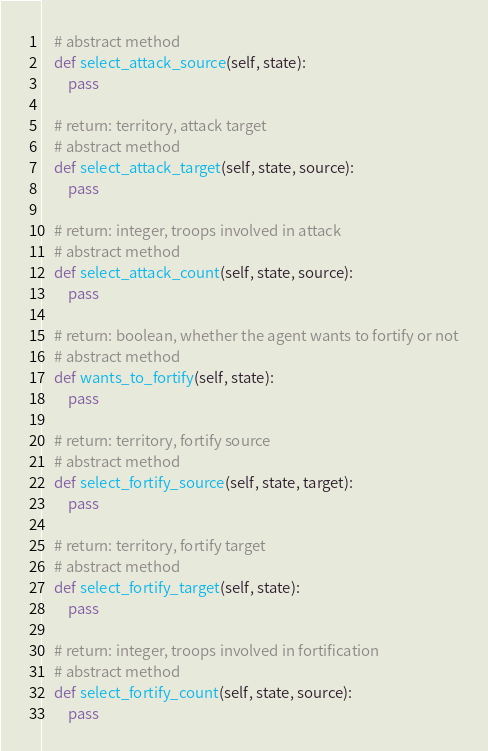<code> <loc_0><loc_0><loc_500><loc_500><_Python_>    # abstract method
    def select_attack_source(self, state):
        pass

    # return: territory, attack target
    # abstract method
    def select_attack_target(self, state, source):
        pass

    # return: integer, troops involved in attack
    # abstract method
    def select_attack_count(self, state, source):
        pass

    # return: boolean, whether the agent wants to fortify or not
    # abstract method
    def wants_to_fortify(self, state):
        pass

    # return: territory, fortify source
    # abstract method
    def select_fortify_source(self, state, target):
        pass

    # return: territory, fortify target
    # abstract method
    def select_fortify_target(self, state):
        pass

    # return: integer, troops involved in fortification
    # abstract method
    def select_fortify_count(self, state, source):
        pass
</code> 